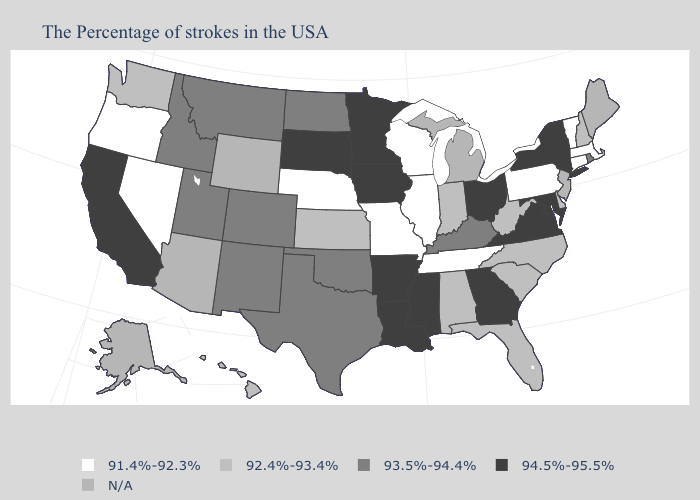What is the value of Tennessee?
Keep it brief. 91.4%-92.3%. Does the first symbol in the legend represent the smallest category?
Quick response, please. Yes. Name the states that have a value in the range 94.5%-95.5%?
Concise answer only. New York, Maryland, Virginia, Ohio, Georgia, Mississippi, Louisiana, Arkansas, Minnesota, Iowa, South Dakota, California. What is the value of Iowa?
Quick response, please. 94.5%-95.5%. Among the states that border Indiana , which have the highest value?
Give a very brief answer. Ohio. Name the states that have a value in the range 93.5%-94.4%?
Quick response, please. Rhode Island, Kentucky, Oklahoma, Texas, North Dakota, Colorado, New Mexico, Utah, Montana, Idaho. Is the legend a continuous bar?
Answer briefly. No. What is the lowest value in the Northeast?
Quick response, please. 91.4%-92.3%. Does Minnesota have the highest value in the MidWest?
Short answer required. Yes. Which states hav the highest value in the MidWest?
Be succinct. Ohio, Minnesota, Iowa, South Dakota. Does the first symbol in the legend represent the smallest category?
Short answer required. Yes. Among the states that border Illinois , does Iowa have the highest value?
Short answer required. Yes. Does the first symbol in the legend represent the smallest category?
Short answer required. Yes. 